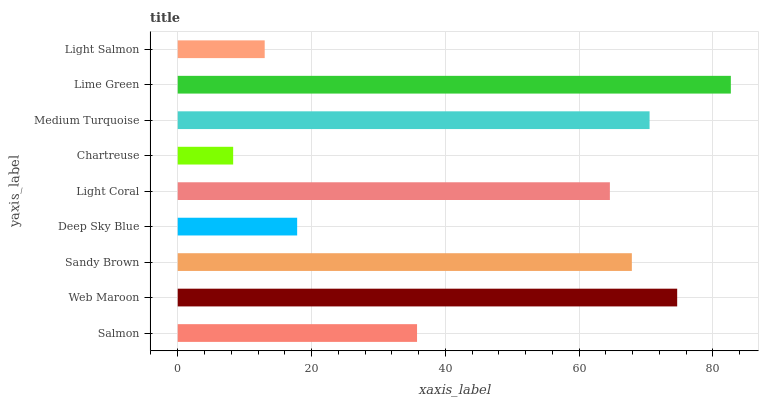Is Chartreuse the minimum?
Answer yes or no. Yes. Is Lime Green the maximum?
Answer yes or no. Yes. Is Web Maroon the minimum?
Answer yes or no. No. Is Web Maroon the maximum?
Answer yes or no. No. Is Web Maroon greater than Salmon?
Answer yes or no. Yes. Is Salmon less than Web Maroon?
Answer yes or no. Yes. Is Salmon greater than Web Maroon?
Answer yes or no. No. Is Web Maroon less than Salmon?
Answer yes or no. No. Is Light Coral the high median?
Answer yes or no. Yes. Is Light Coral the low median?
Answer yes or no. Yes. Is Chartreuse the high median?
Answer yes or no. No. Is Web Maroon the low median?
Answer yes or no. No. 